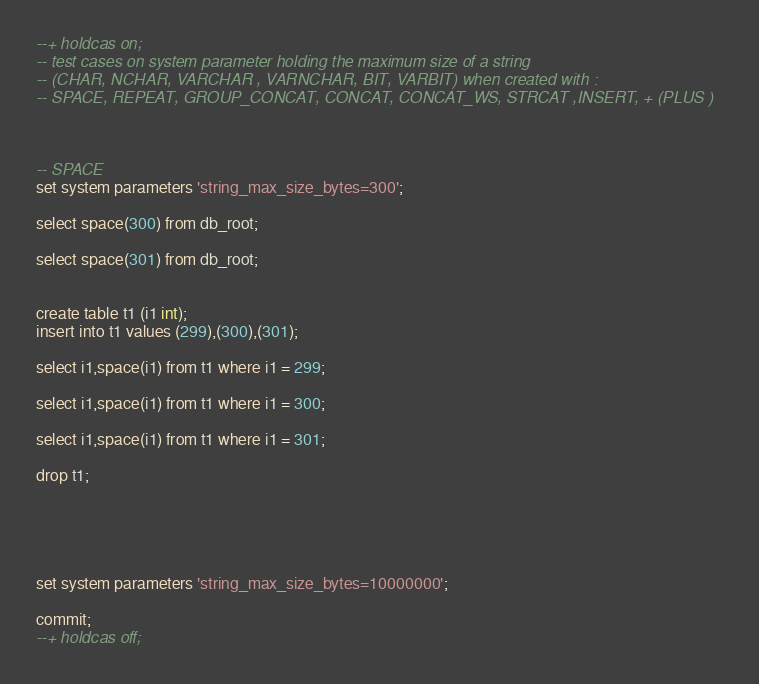<code> <loc_0><loc_0><loc_500><loc_500><_SQL_>--+ holdcas on;
-- test cases on system parameter holding the maximum size of a string
-- (CHAR, NCHAR, VARCHAR , VARNCHAR, BIT, VARBIT) when created with :
-- SPACE, REPEAT, GROUP_CONCAT, CONCAT, CONCAT_WS, STRCAT ,INSERT, + (PLUS )



-- SPACE
set system parameters 'string_max_size_bytes=300';

select space(300) from db_root;

select space(301) from db_root;


create table t1 (i1 int);
insert into t1 values (299),(300),(301);

select i1,space(i1) from t1 where i1 = 299;

select i1,space(i1) from t1 where i1 = 300;

select i1,space(i1) from t1 where i1 = 301;

drop t1;





set system parameters 'string_max_size_bytes=10000000';

commit;
--+ holdcas off;
</code> 